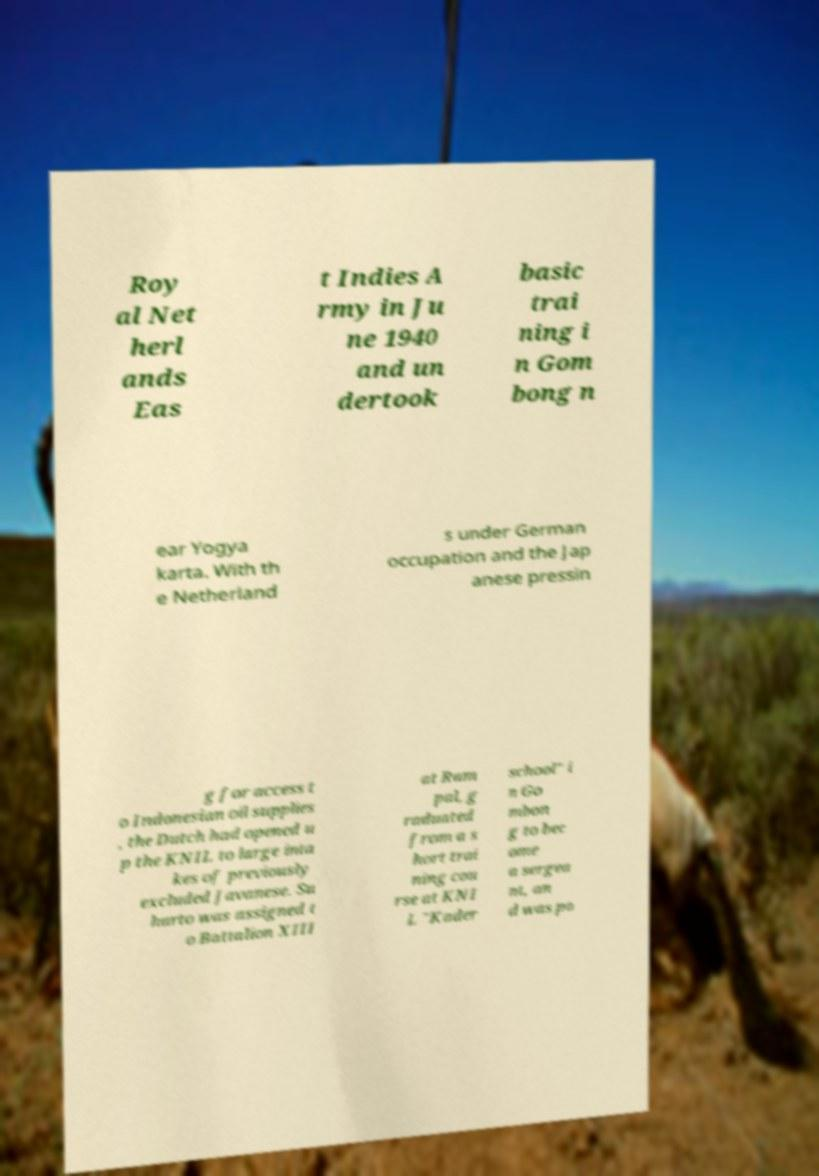I need the written content from this picture converted into text. Can you do that? Roy al Net herl ands Eas t Indies A rmy in Ju ne 1940 and un dertook basic trai ning i n Gom bong n ear Yogya karta. With th e Netherland s under German occupation and the Jap anese pressin g for access t o Indonesian oil supplies , the Dutch had opened u p the KNIL to large inta kes of previously excluded Javanese. Su harto was assigned t o Battalion XIII at Ram pal, g raduated from a s hort trai ning cou rse at KNI L "Kader school" i n Go mbon g to bec ome a sergea nt, an d was po 